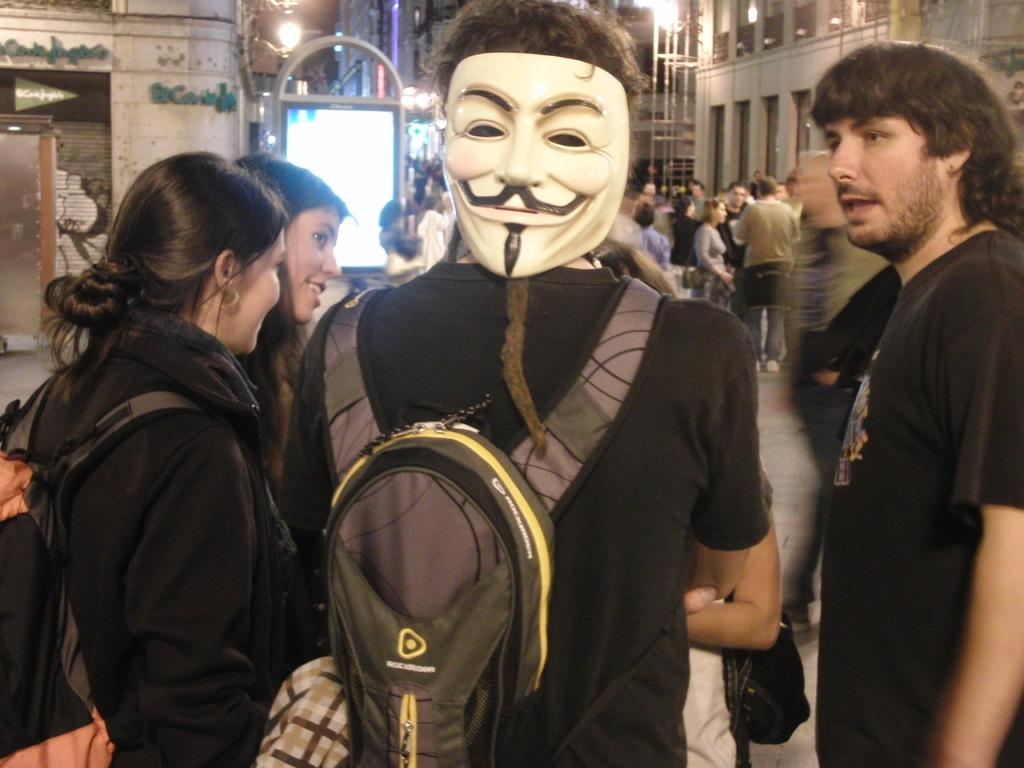How many people are in the image? There are people in the image, but the exact number is not specified. What are the people wearing? The people are wearing bags. What are some of the people doing in the image? Some people are standing. Can you describe the appearance of one person in the image? One person is wearing a mask. What can be seen in the background of the image? In the background, there are buildings, lights, poles, and boards. What type of meat is being cooked on the grill in the image? There is no grill or meat present in the image. How many rings does the person in the image have on their fingers? There is no mention of rings or fingers in the image. --- Facts: 1. There is a car in the image. 2. The car is red. 3. The car has four wheels. 4. There are people in the car. 5. The car has a roof. 6. The car has windows. Absurd Topics: fish, rainbow, dance Conversation: What is the main subject of the image? The main subject of the image is a car. What color is the car? The car is red. How many wheels does the car have? The car has four wheels. Are there any people inside the car? Yes, there are people in the car. What features does the car have? The car has a roof and windows. Reasoning: Let's think step by step in order to produce the conversation. We start by identifying the main subject of the image, which is the car. Then, we describe the color and number of wheels of the car. Next, we mention the presence of people inside the car. Finally, we describe the features of the car, including the roof and windows. Absurd Question/Answer: Can you see any fish swimming in the car's windows in the image? No, there are no fish visible in the car's windows in the image. Is there a rainbow arching over the car in the image? No, there is no rainbow present in the image. 